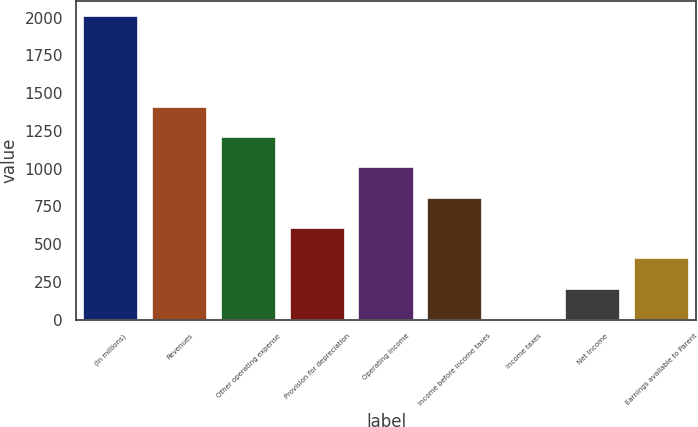Convert chart. <chart><loc_0><loc_0><loc_500><loc_500><bar_chart><fcel>(In millions)<fcel>Revenues<fcel>Other operating expense<fcel>Provision for depreciation<fcel>Operating Income<fcel>Income before income taxes<fcel>Income taxes<fcel>Net Income<fcel>Earnings available to Parent<nl><fcel>2010<fcel>1408.32<fcel>1207.76<fcel>606.08<fcel>1007.2<fcel>806.64<fcel>4.4<fcel>204.96<fcel>405.52<nl></chart> 